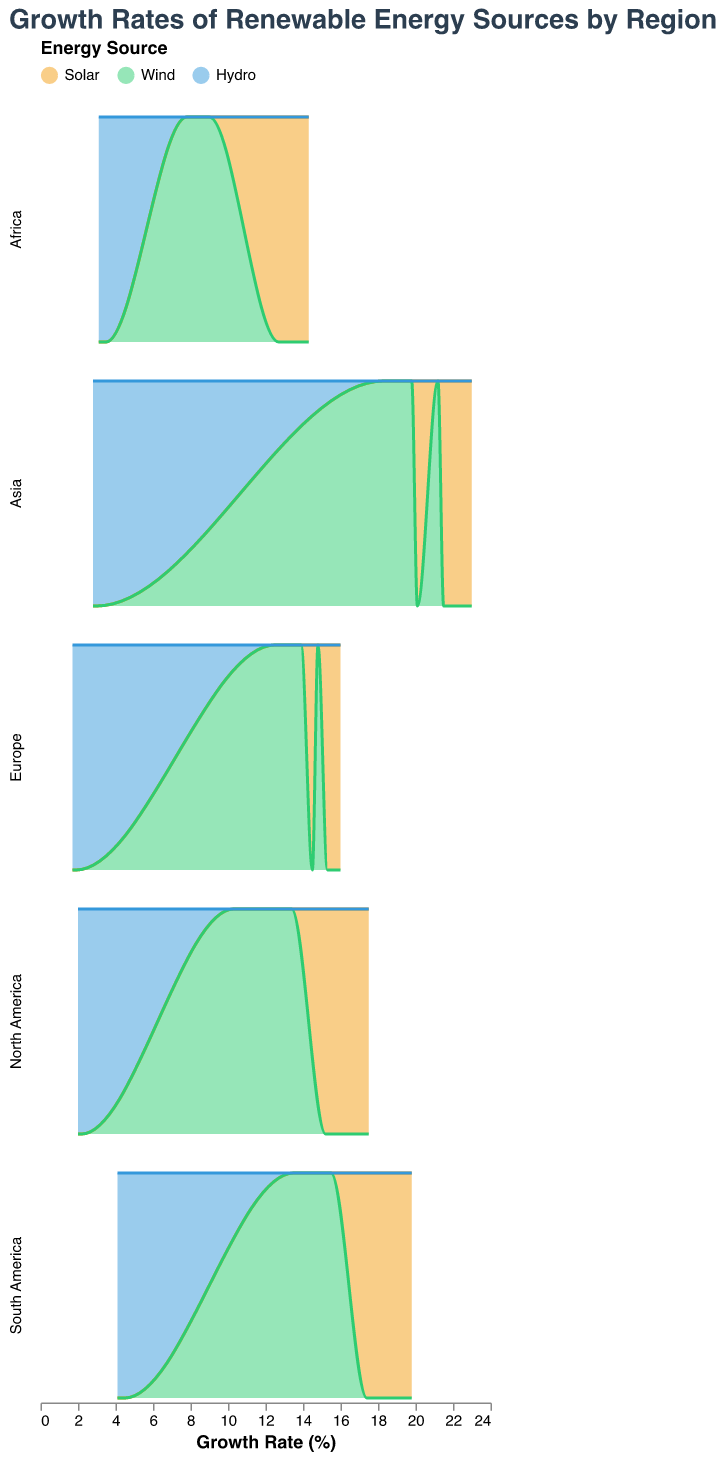What is the title of the figure? The title is displayed prominently at the top of the figure. It reads "Growth Rates of Renewable Energy Sources by Region".
Answer: Growth Rates of Renewable Energy Sources by Region What renewable energy sources are being compared in the figure? The legend at the top of the figure shows three energy sources: Solar, Wind, and Hydro. These are indicated by distinct colors.
Answer: Solar, Wind, Hydro Which region had the highest growth rate for solar energy in 2022? By examining the area plot for each row corresponding to the different regions, Asia has the highest growth rate for solar energy in 2022, which is 23.0%.
Answer: Asia How does the growth rate of wind energy in North America in 2022 compare to that in Europe in the same year? By comparing the densities of the respective plots, North America's wind energy growth rate in 2022 is 13.4%, whereas Europe's is 14.8%.
Answer: Europe has a higher growth rate Which renewable energy source shows the least growth overall across all regions from 2020 to 2022? Hydro consistently shows the lowest growth rates in all regions over the three years.
Answer: Hydro For which regions has the growth rate of hydro energy decreased over the years? By observing the trends in the plots for each region, hydro energy growth rates have decreased in North America, Europe, Asia, South America, and Africa over the years.
Answer: All regions Which region had a higher growth rate for wind energy in 2021, North America, or Africa? The density plot for wind energy in North America shows a growth rate of 12.0% in 2021, while Africa shows a growth rate of 8.5% for the same year.
Answer: North America Comparing solar energy growth rates, which two regions have the closest growth rates in 2022? By analyzing the values on the x-axis for solar energy growth rates in 2022, Europe (16.0%) and North America (17.5%) show the closest growth rates.
Answer: Europe, North America What trend can be observed for solar energy growth in Asia from 2020 to 2022? The density plot for solar energy in Asia demonstrates an increasing trend from 20.1% in 2020, 21.5% in 2021, to 23.0% in 2022.
Answer: Increasing trend Which region had the lowest solar energy growth rate in 2020? The area plot and density pattern show that Africa had the lowest solar energy growth rate in 2020 at 12.7%.
Answer: Africa 